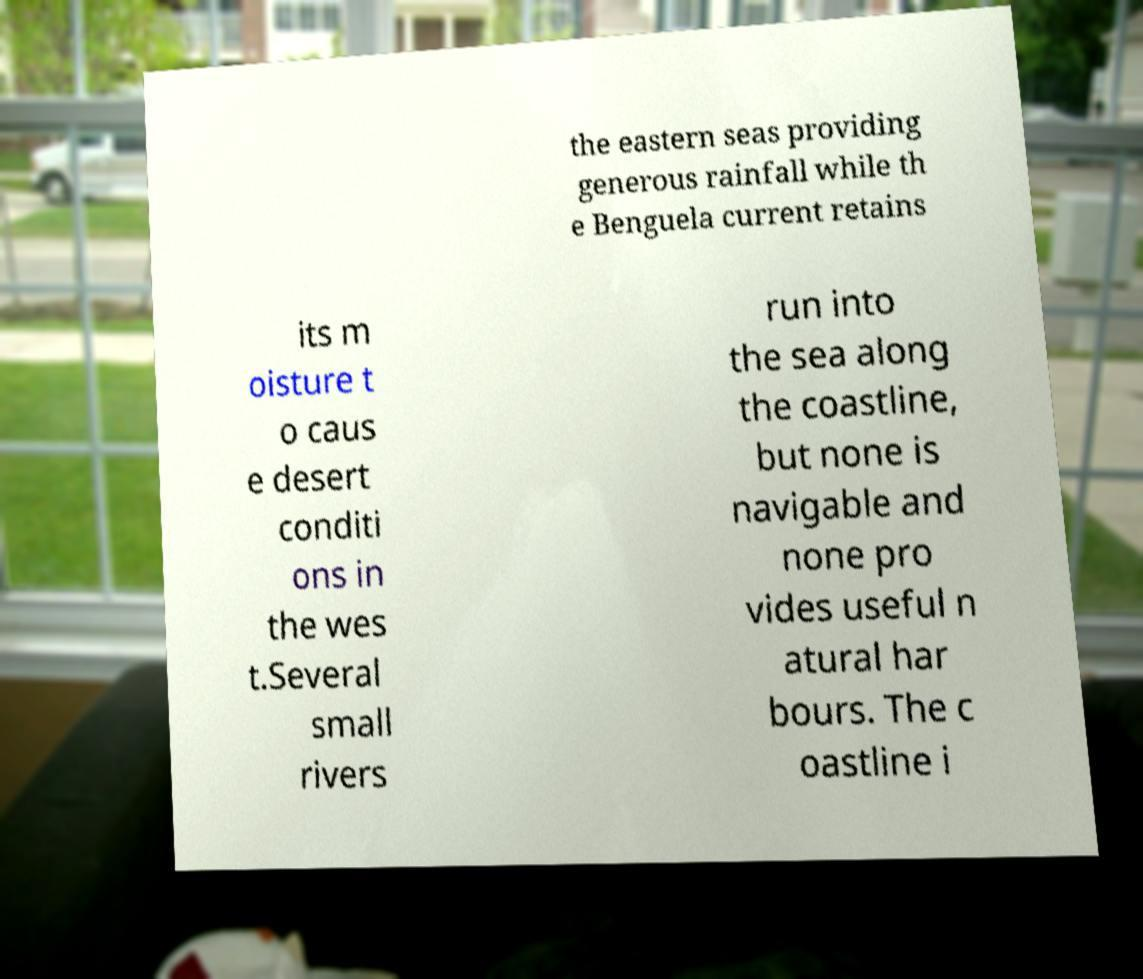Could you assist in decoding the text presented in this image and type it out clearly? the eastern seas providing generous rainfall while th e Benguela current retains its m oisture t o caus e desert conditi ons in the wes t.Several small rivers run into the sea along the coastline, but none is navigable and none pro vides useful n atural har bours. The c oastline i 